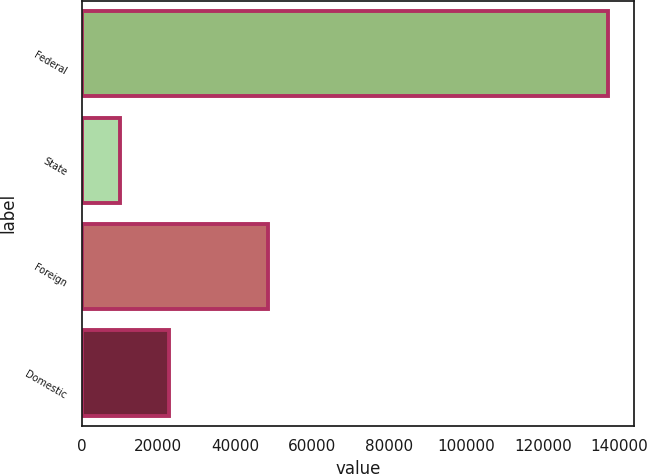Convert chart to OTSL. <chart><loc_0><loc_0><loc_500><loc_500><bar_chart><fcel>Federal<fcel>State<fcel>Foreign<fcel>Domestic<nl><fcel>136860<fcel>9972<fcel>48403<fcel>22660.8<nl></chart> 